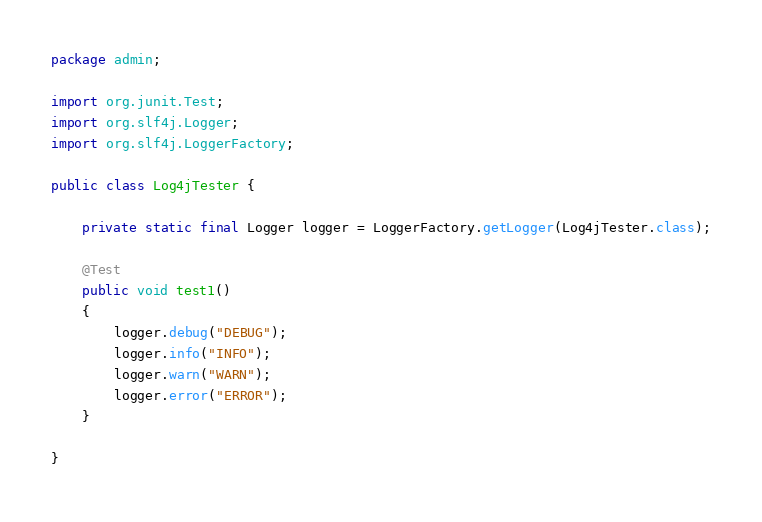Convert code to text. <code><loc_0><loc_0><loc_500><loc_500><_Java_>package admin;

import org.junit.Test;
import org.slf4j.Logger;
import org.slf4j.LoggerFactory;

public class Log4jTester {
	
	private static final Logger logger = LoggerFactory.getLogger(Log4jTester.class);
	
	@Test
	public void test1()
	{
		logger.debug("DEBUG");
		logger.info("INFO");
		logger.warn("WARN");
		logger.error("ERROR");
	}
	
}
</code> 